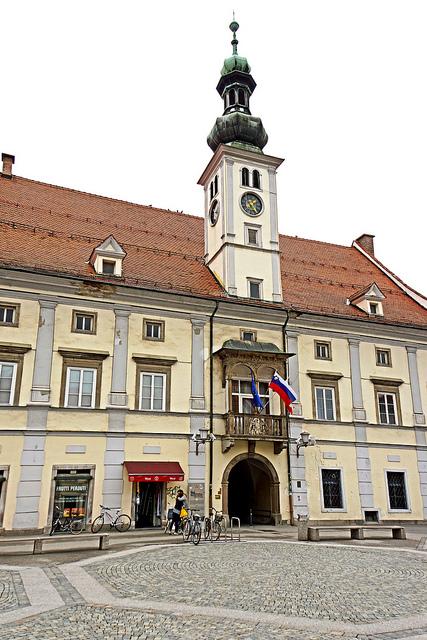How many flags are by the building's entrance?
Answer briefly. 2. What is the decoration above the clock tower?
Short answer required. Point. Is this a City Hall?
Short answer required. Yes. What color are the steps on the white building?
Keep it brief. Gray. What kind of roof in on the building?
Keep it brief. Tile. 